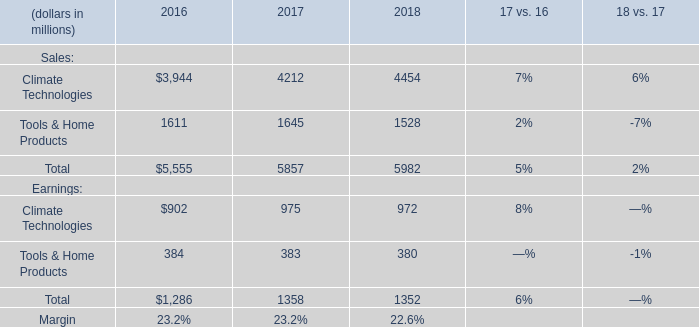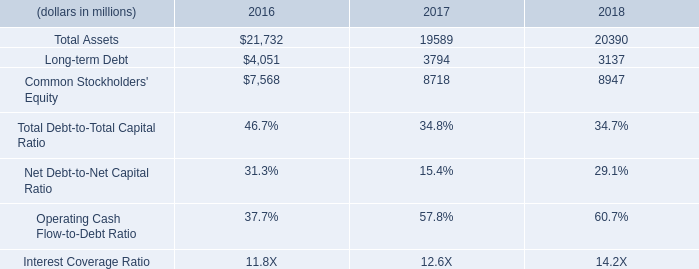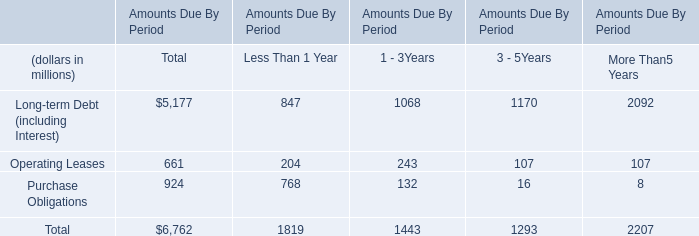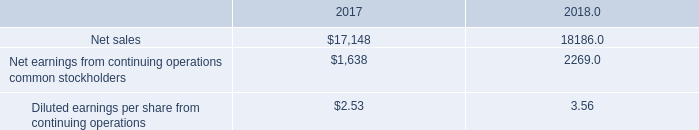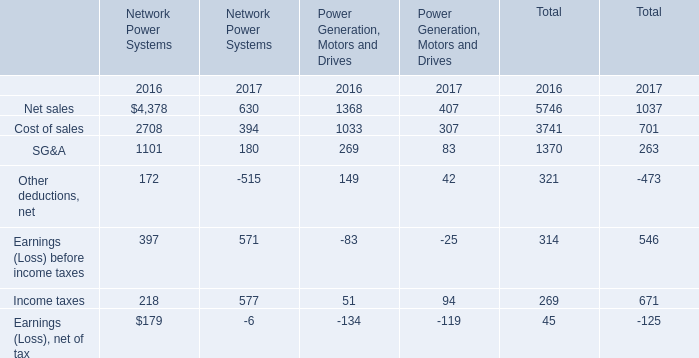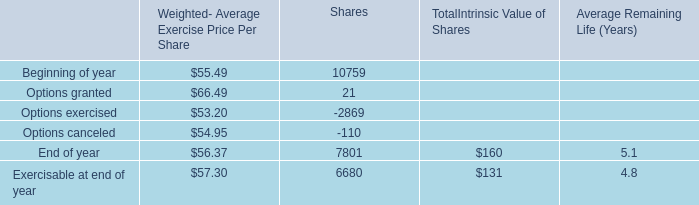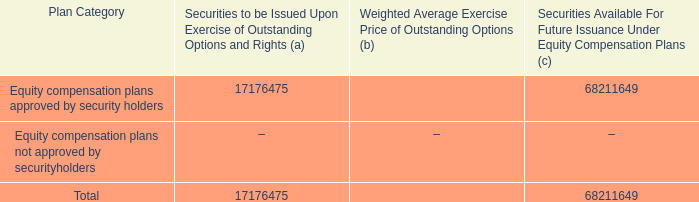What's the increasing rate of Earnings (Loss) before income taxes in 2017? 
Computations: ((571 - 397) / 397)
Answer: 0.43829. 